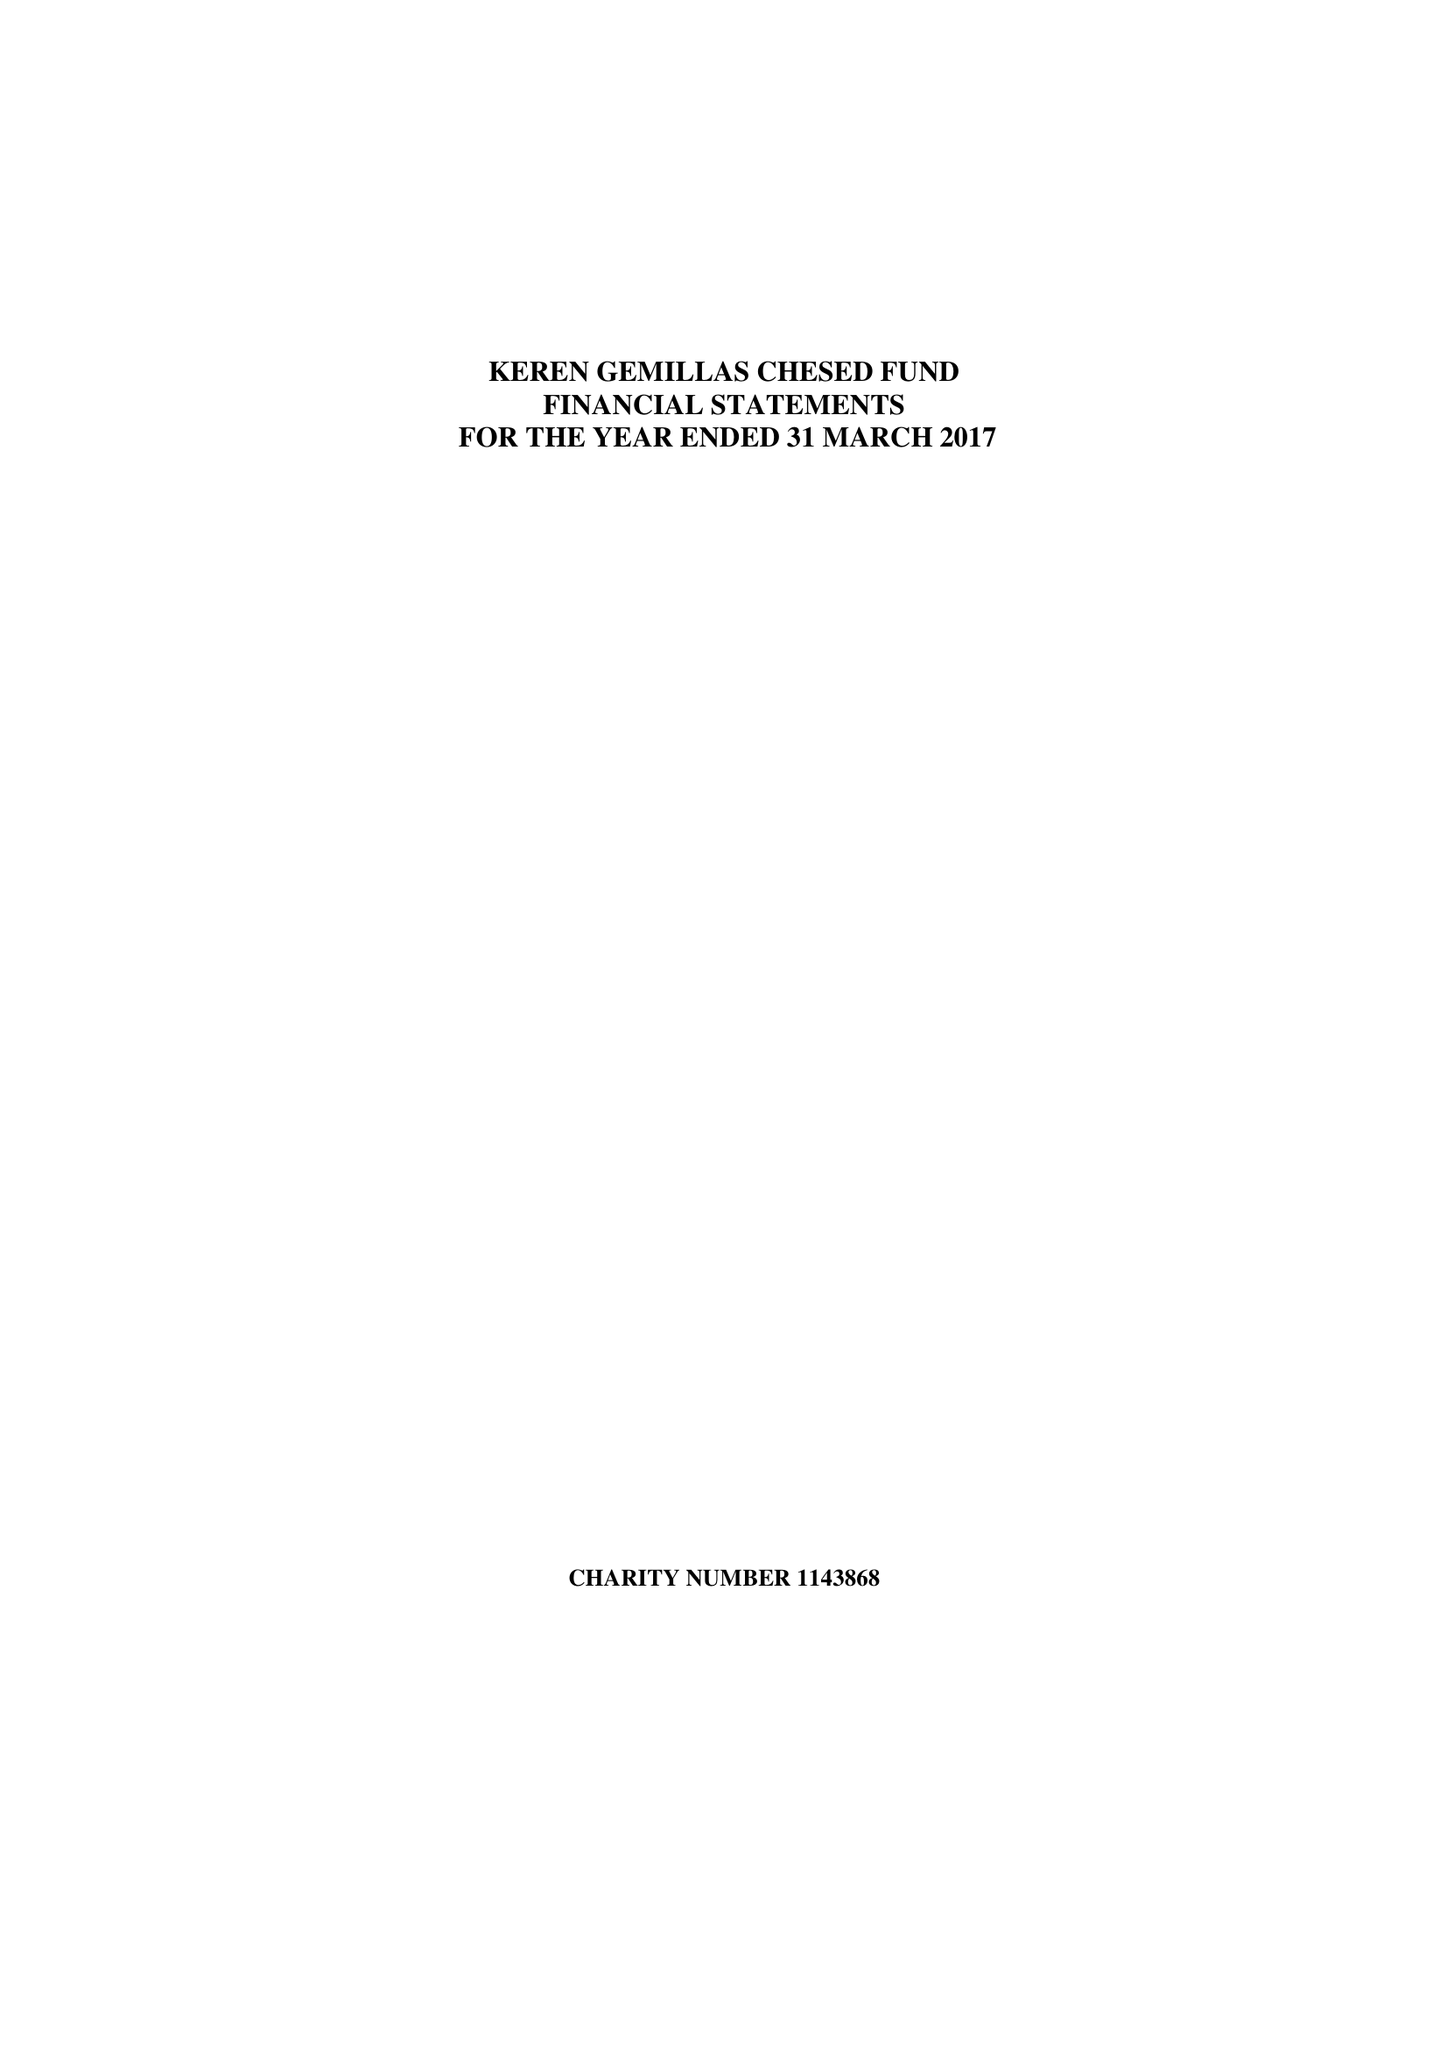What is the value for the income_annually_in_british_pounds?
Answer the question using a single word or phrase. 111526.00 